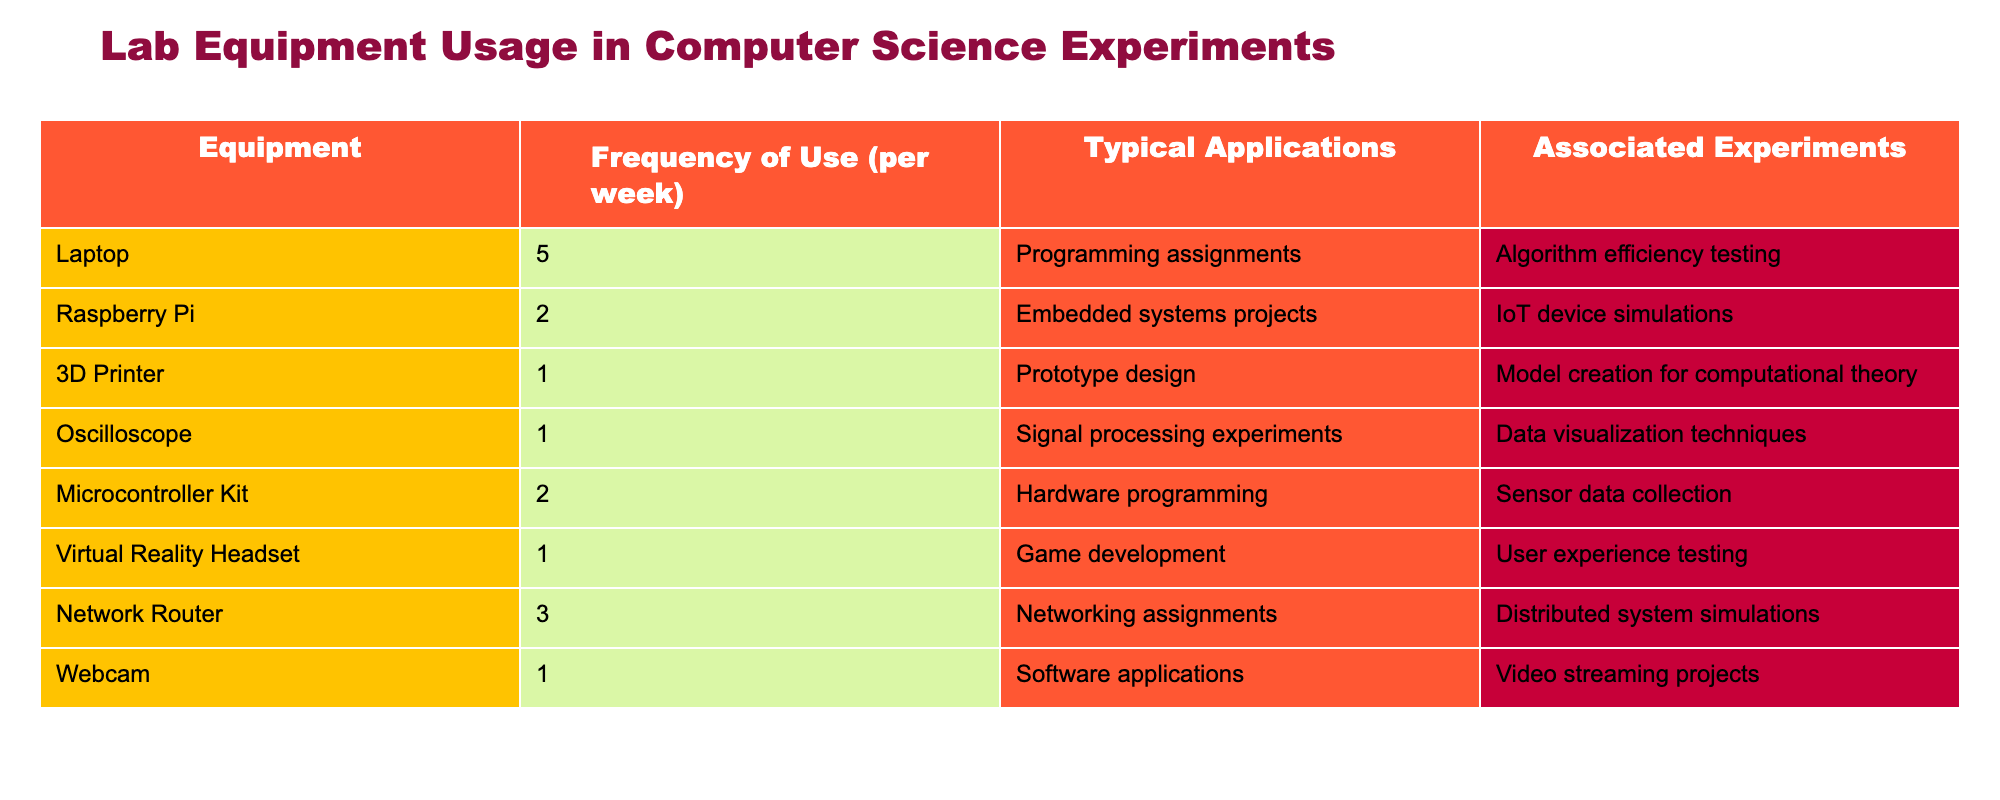What equipment is used most frequently in computer science experiments? By reviewing the "Frequency of Use (per week)" column in the table, we find that the Laptop has the highest frequency at 5 times a week, meaning it is the most used equipment.
Answer: Laptop What is the typical application for Raspberry Pi? The table shows that the typical application for Raspberry Pi is in embedded systems projects.
Answer: Embedded systems projects Which equipment is used for game development? According to the table, the equipment used for game development is the Virtual Reality Headset.
Answer: Virtual Reality Headset What’s the total frequency of use for all equipment listed in the table? To find the total frequency of use, we add the frequencies: 5 (Laptop) + 2 (Raspberry Pi) + 1 (3D Printer) + 1 (Oscilloscope) + 2 (Microcontroller Kit) + 1 (VR Headset) + 3 (Network Router) + 1 (Webcam) = 16.
Answer: 16 Is the 3D Printer used more than the Oscilloscope? By comparing the frequencies, we see that the 3D Printer is used 1 time a week, and the Oscilloscope is also used 1 time a week. Thus, they are used equally, making the answer "No".
Answer: No What is the average frequency of equipment use per week across all items? To calculate the average, we sum the frequencies (16) and divide by the number of equipment types (8): 16 / 8 = 2, giving us an average frequency of 2.
Answer: 2 Is the Microcontroller Kit used more frequently than the Network Router? The Microcontroller Kit has a frequency of 2 times per week, while the Network Router has a frequency of 3 times per week. Thus, the answer is "No".
Answer: No Which equipment is used for data visualization techniques? From the table, we can see that the Oscilloscope is used for data visualization techniques.
Answer: Oscilloscope 